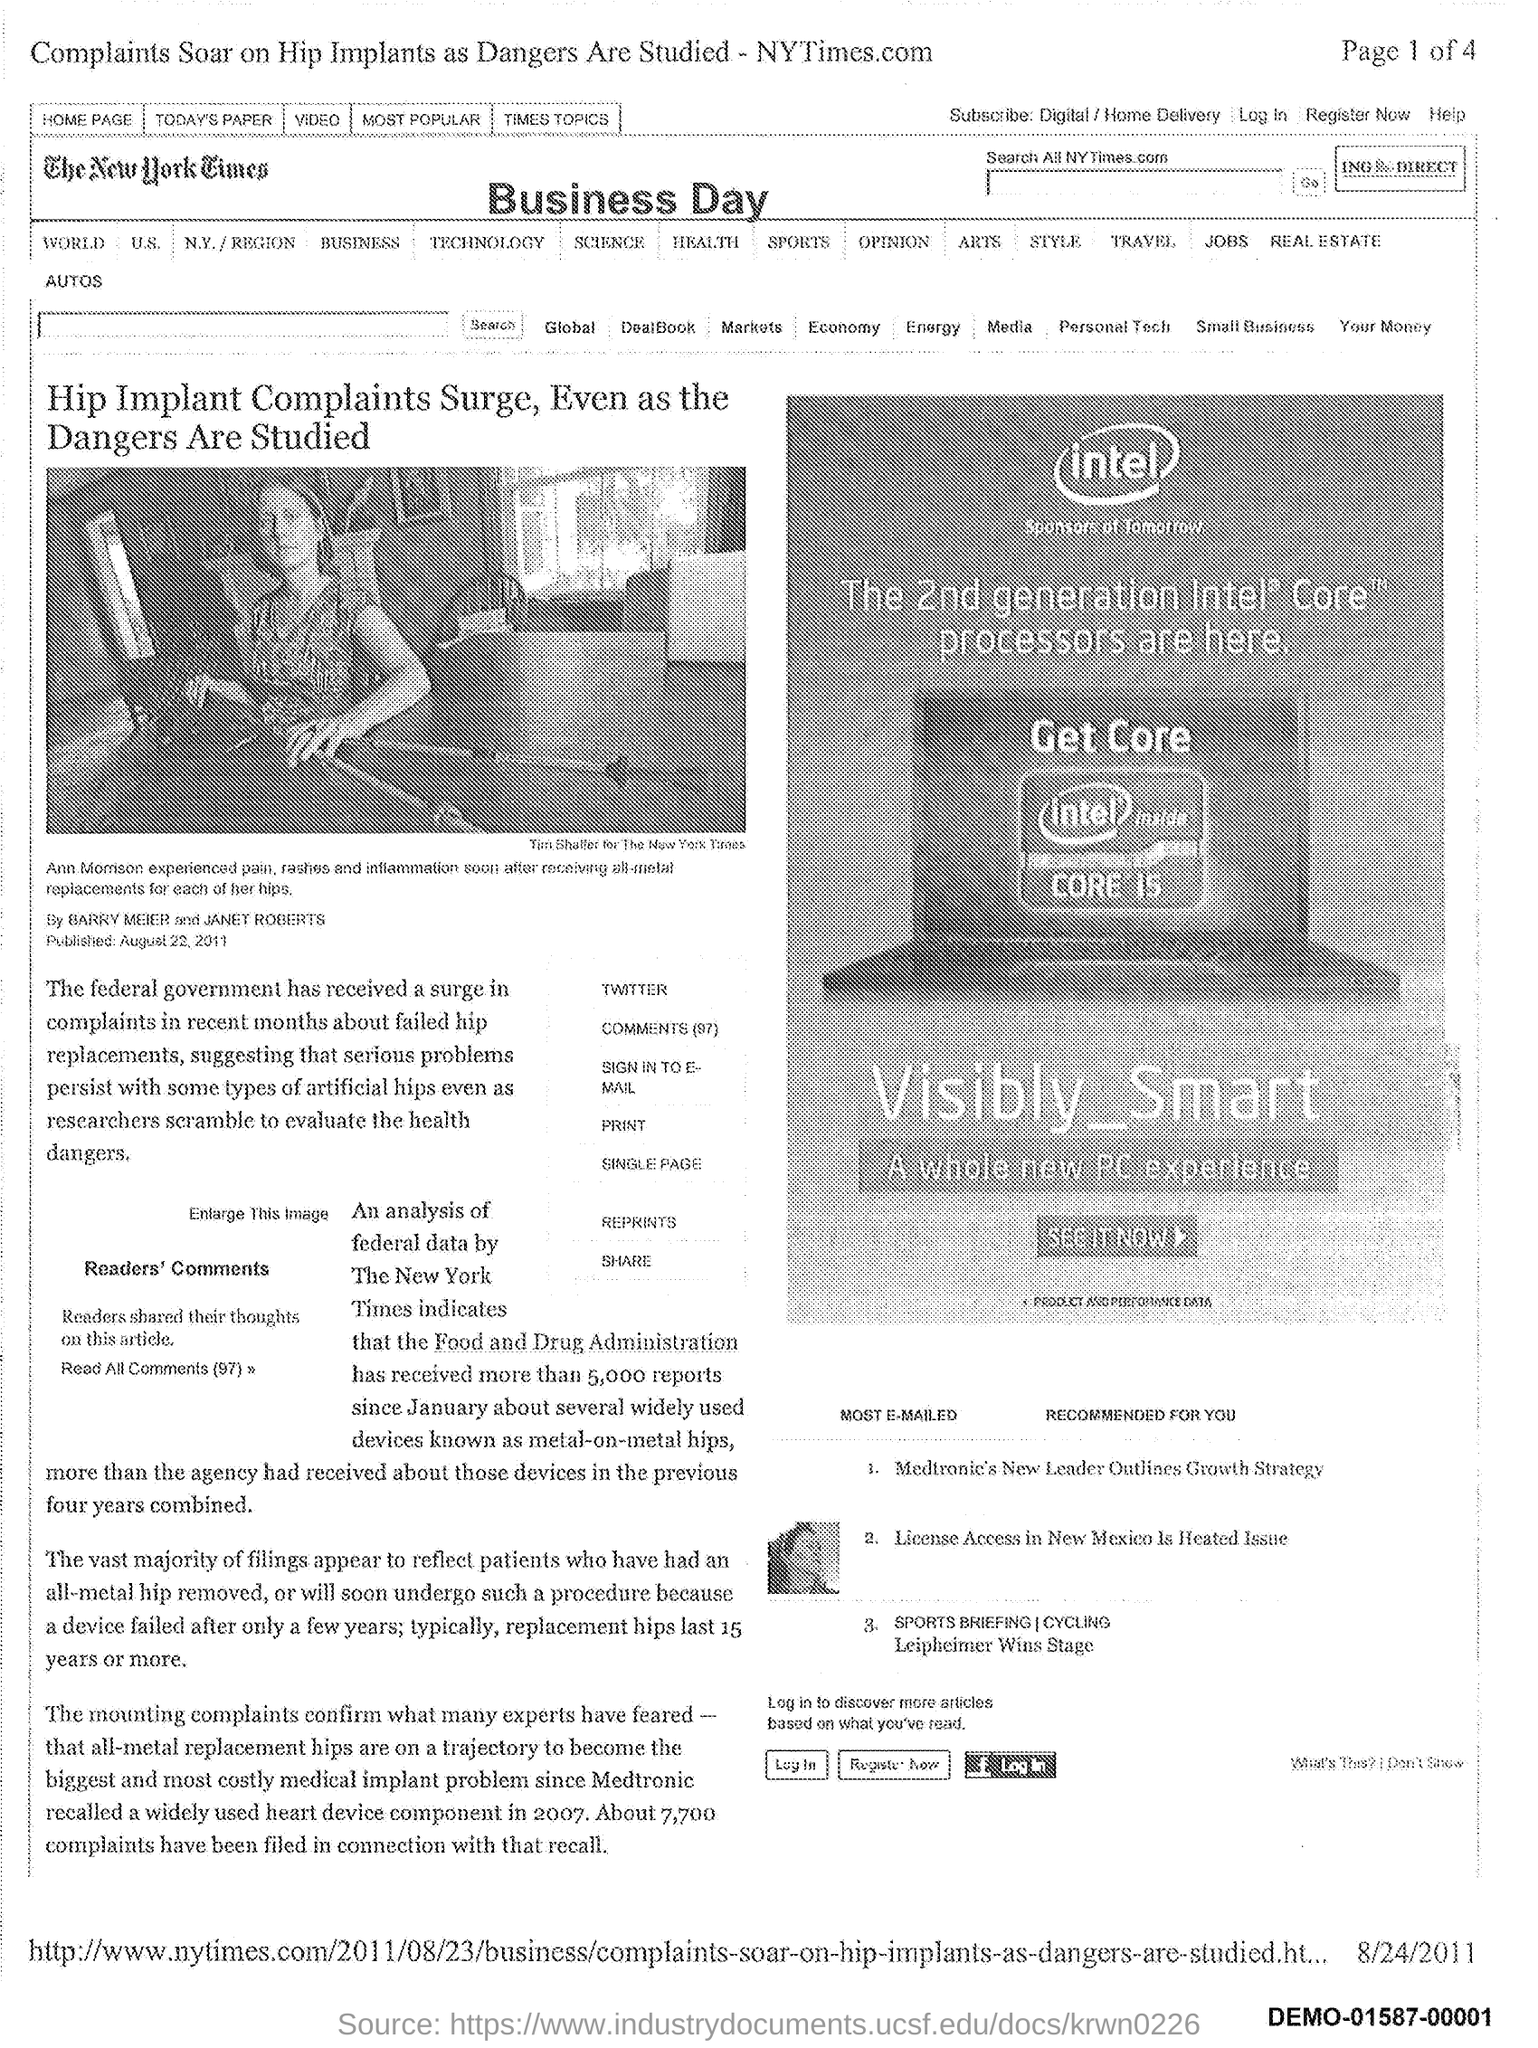What is the name of the newspaper mentioned in the document?
Your response must be concise. The New York Times. 